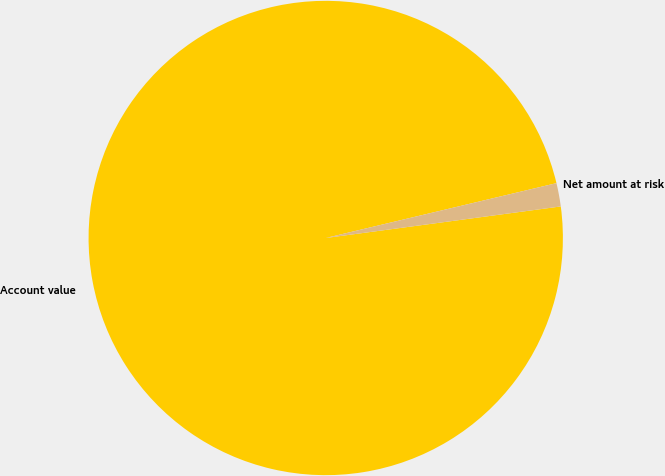Convert chart to OTSL. <chart><loc_0><loc_0><loc_500><loc_500><pie_chart><fcel>Account value<fcel>Net amount at risk<nl><fcel>98.41%<fcel>1.59%<nl></chart> 